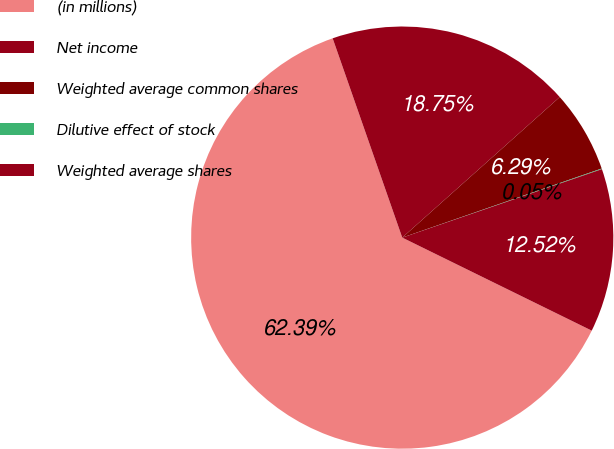Convert chart to OTSL. <chart><loc_0><loc_0><loc_500><loc_500><pie_chart><fcel>(in millions)<fcel>Net income<fcel>Weighted average common shares<fcel>Dilutive effect of stock<fcel>Weighted average shares<nl><fcel>62.39%<fcel>18.75%<fcel>6.29%<fcel>0.05%<fcel>12.52%<nl></chart> 